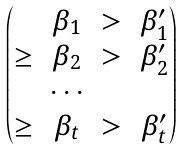<formula> <loc_0><loc_0><loc_500><loc_500>\begin{pmatrix} & \beta _ { 1 } & > & \beta ^ { \prime } _ { 1 } \\ \geq & \beta _ { 2 } & > & \beta ^ { \prime } _ { 2 } \\ & \cdots \\ \geq & \beta _ { t } & > & \beta ^ { \prime } _ { t } \end{pmatrix}</formula> 